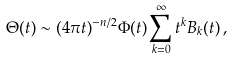Convert formula to latex. <formula><loc_0><loc_0><loc_500><loc_500>\Theta ( t ) \sim ( 4 \pi t ) ^ { - n / 2 } \Phi ( t ) \sum _ { k = 0 } ^ { \infty } t ^ { k } B _ { k } ( t ) \, ,</formula> 